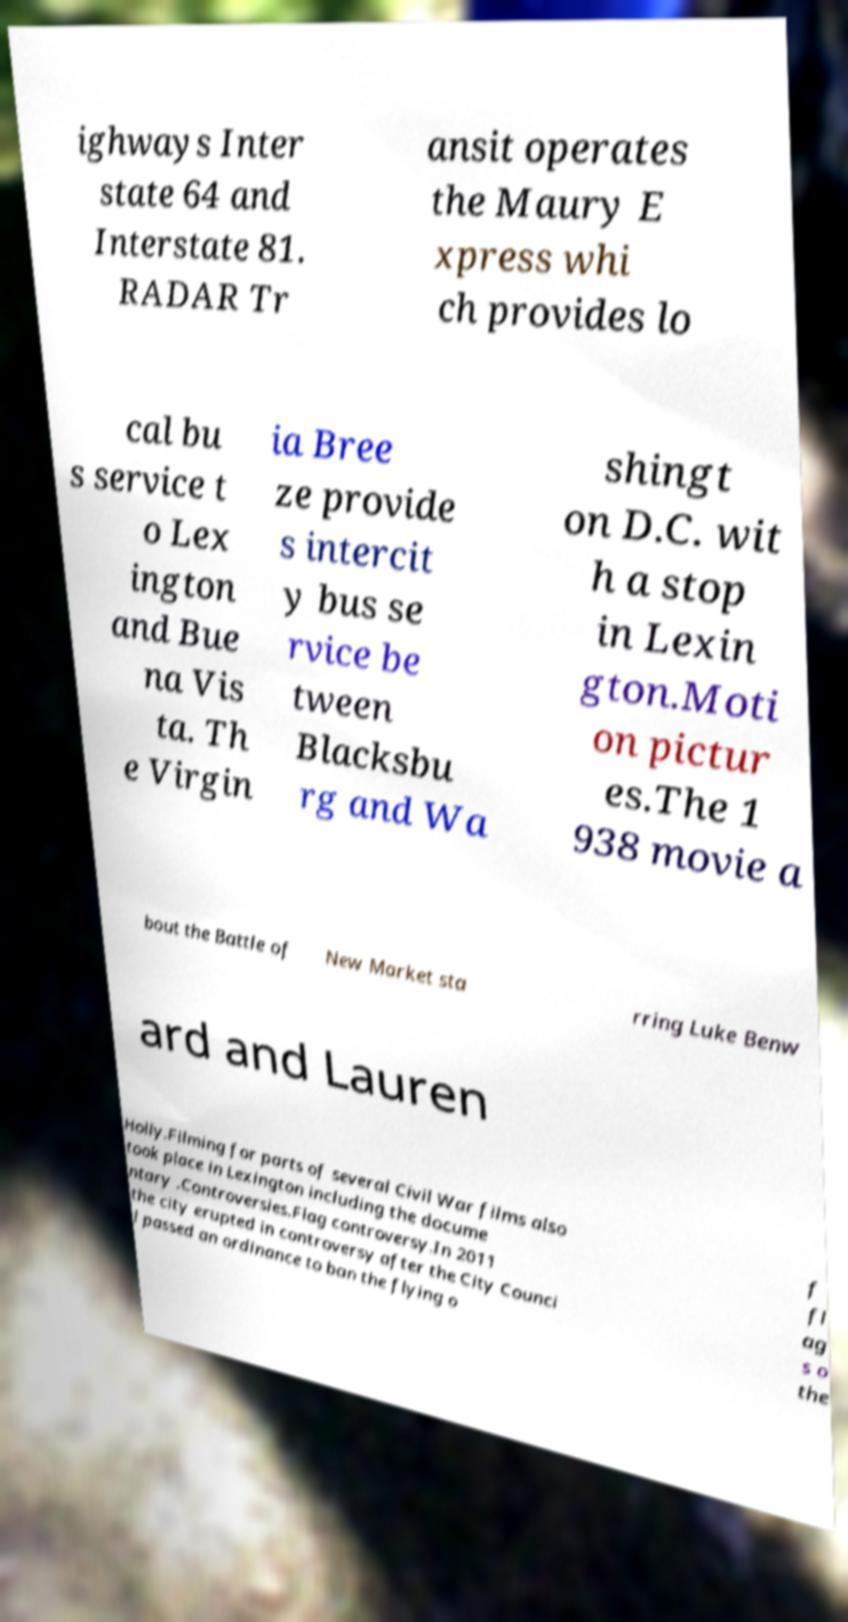I need the written content from this picture converted into text. Can you do that? ighways Inter state 64 and Interstate 81. RADAR Tr ansit operates the Maury E xpress whi ch provides lo cal bu s service t o Lex ington and Bue na Vis ta. Th e Virgin ia Bree ze provide s intercit y bus se rvice be tween Blacksbu rg and Wa shingt on D.C. wit h a stop in Lexin gton.Moti on pictur es.The 1 938 movie a bout the Battle of New Market sta rring Luke Benw ard and Lauren Holly.Filming for parts of several Civil War films also took place in Lexington including the docume ntary .Controversies.Flag controversy.In 2011 the city erupted in controversy after the City Counci l passed an ordinance to ban the flying o f fl ag s o the 